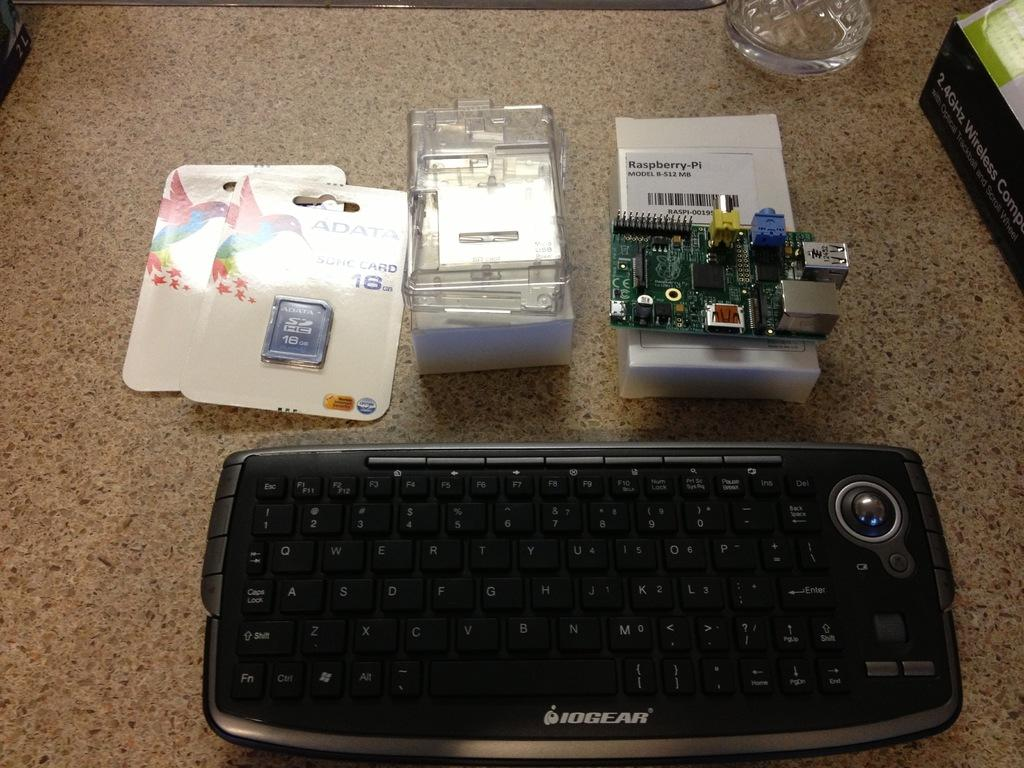<image>
Create a compact narrative representing the image presented. A IOGEAR black computer keyboard and other hardware parts on a counter. 